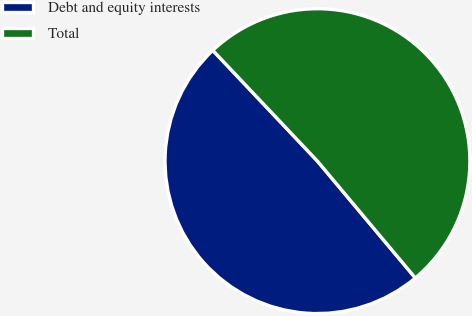<chart> <loc_0><loc_0><loc_500><loc_500><pie_chart><fcel>Debt and equity interests<fcel>Total<nl><fcel>49.05%<fcel>50.95%<nl></chart> 